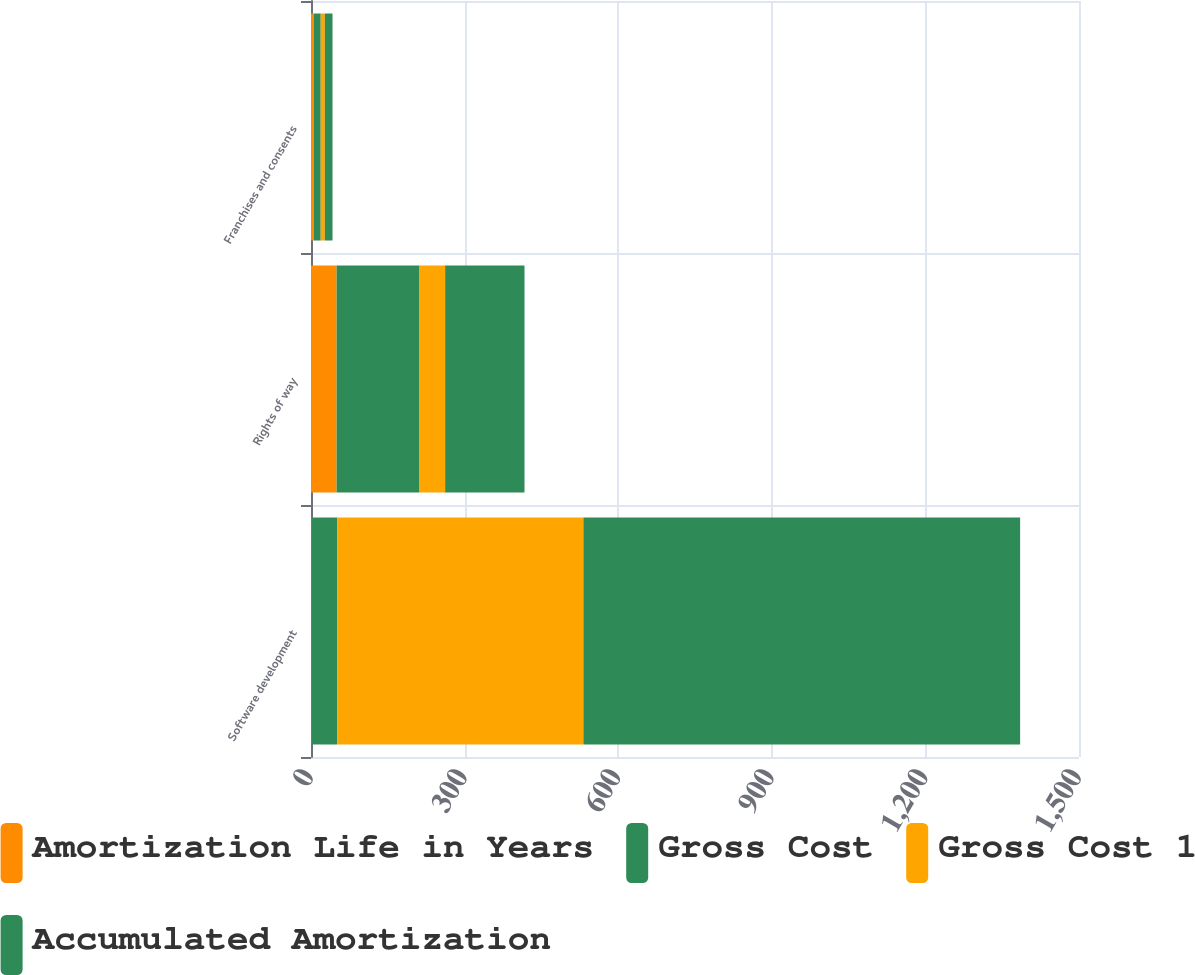<chart> <loc_0><loc_0><loc_500><loc_500><stacked_bar_chart><ecel><fcel>Software development<fcel>Rights of way<fcel>Franchises and consents<nl><fcel>Amortization Life in Years<fcel>1<fcel>50<fcel>5<nl><fcel>Gross Cost<fcel>50<fcel>162<fcel>14<nl><fcel>Gross Cost 1<fcel>481<fcel>50<fcel>8<nl><fcel>Accumulated Amortization<fcel>853<fcel>155<fcel>15<nl></chart> 